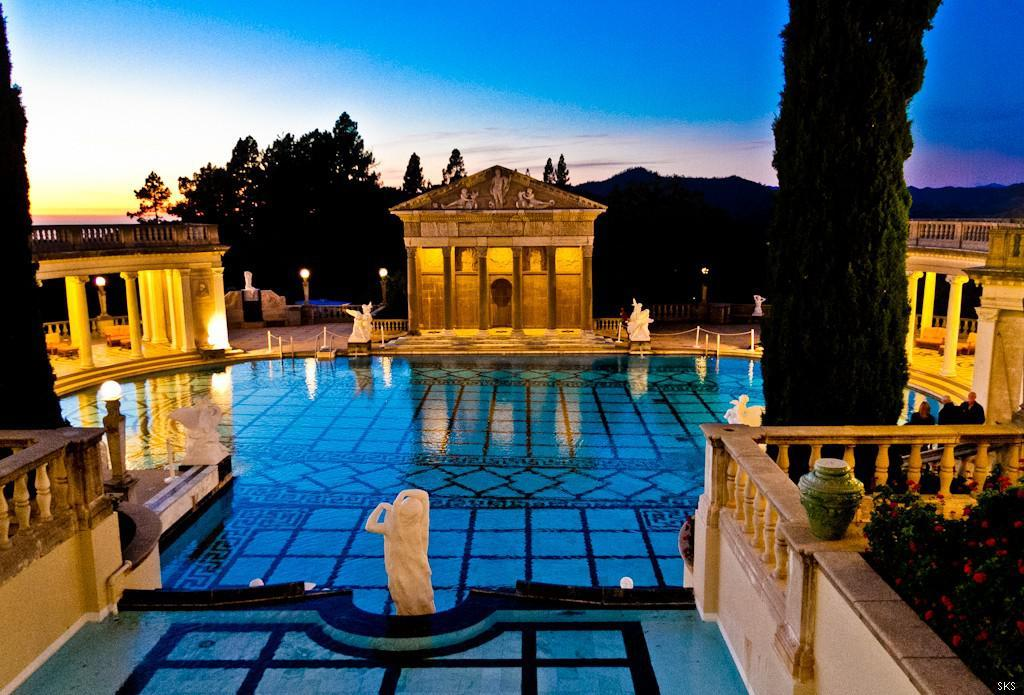What type of statues can be seen in the image? There are white color statues in the image. What body of water is present in the image? There is a swimming-pool in the image. What type of barrier is visible in the image? There is fencing in the image. What type of structures are present to provide illumination? There are light poles in the image. What type of vegetation is present in the image? There are trees in the image. What type of man-made structures are visible in the image? There are buildings in the image. What type of architectural elements can be seen in the image? There are pillars in the image. What type of flowers are present in the image? There are red color flowers in the image. What is the color of the sky in the image? The sky is blue, white, and yellow in color. What type of scarf is the governor wearing in the image? There is no governor or scarf present in the image. What type of ocean can be seen in the image? There is no ocean present in the image; it features a swimming-pool. 